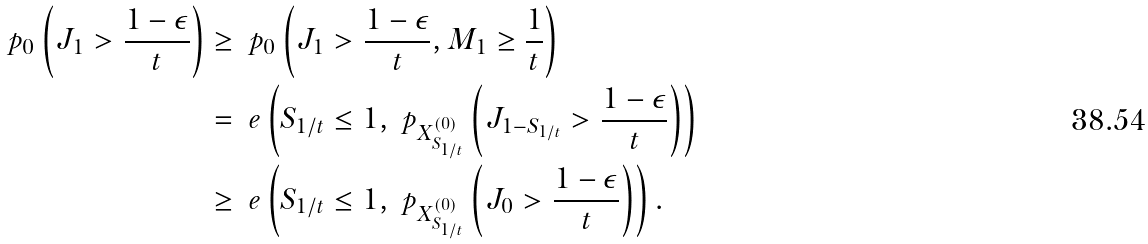<formula> <loc_0><loc_0><loc_500><loc_500>\ p _ { 0 } \left ( J _ { 1 } > \frac { 1 - \epsilon } { t } \right ) & \geq \ p _ { 0 } \left ( J _ { 1 } > \frac { 1 - \epsilon } { t } , M _ { 1 } \geq \frac { 1 } { t } \right ) \\ & = \ e \left ( S _ { 1 / t } \leq 1 , \ p _ { X ^ { ( 0 ) } _ { S _ { 1 / t } } } \left ( J _ { 1 - S _ { 1 / t } } > \frac { 1 - \epsilon } { t } \right ) \right ) \\ & \geq \ e \left ( S _ { 1 / t } \leq 1 , \ p _ { X ^ { ( 0 ) } _ { S _ { 1 / t } } } \left ( J _ { 0 } > \frac { 1 - \epsilon } { t } \right ) \right ) . \\</formula> 